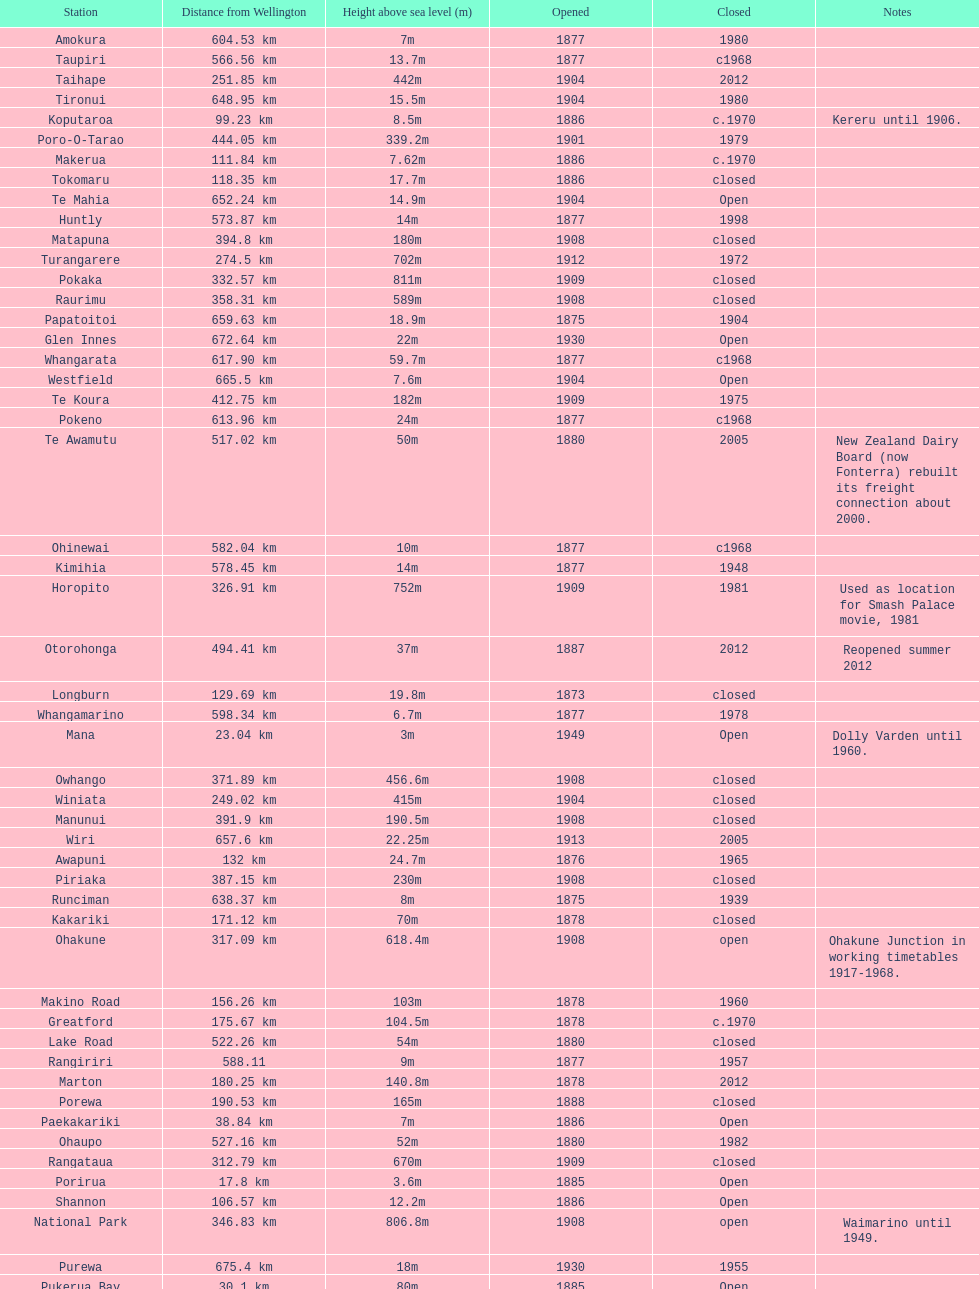How much higher is the takapu road station than the wellington station? 38.6m. 